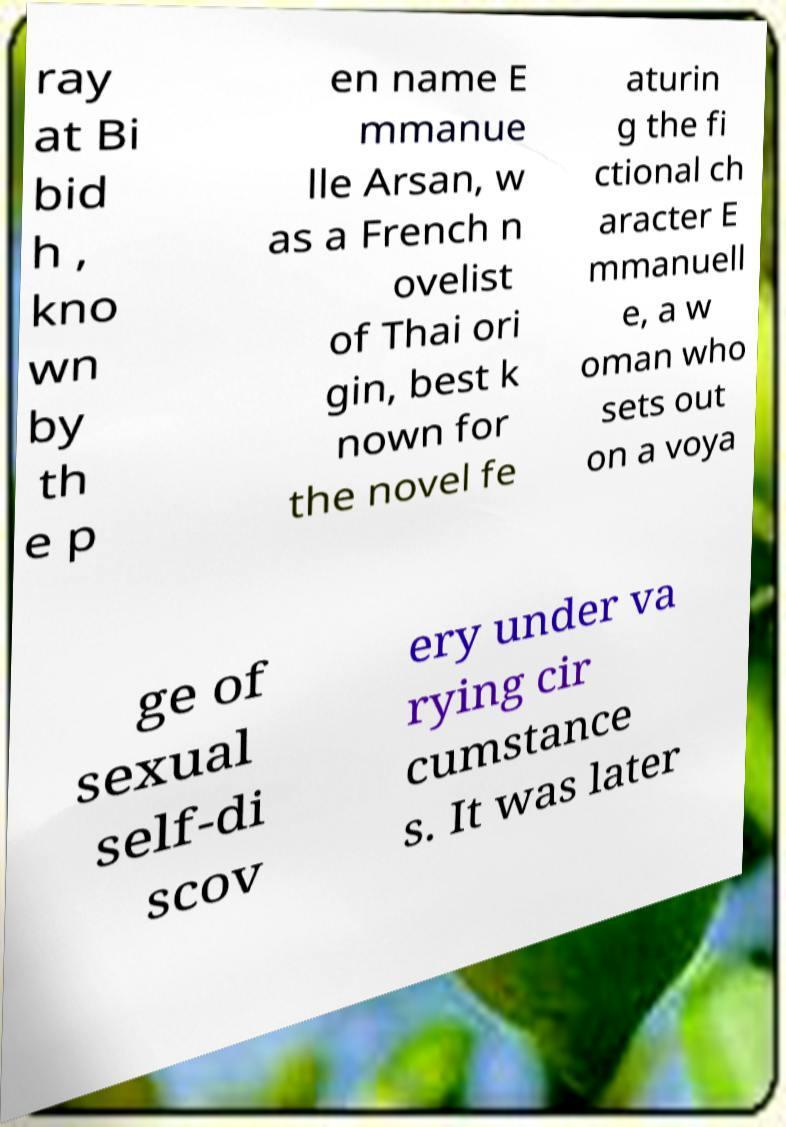Please identify and transcribe the text found in this image. ray at Bi bid h , kno wn by th e p en name E mmanue lle Arsan, w as a French n ovelist of Thai ori gin, best k nown for the novel fe aturin g the fi ctional ch aracter E mmanuell e, a w oman who sets out on a voya ge of sexual self-di scov ery under va rying cir cumstance s. It was later 